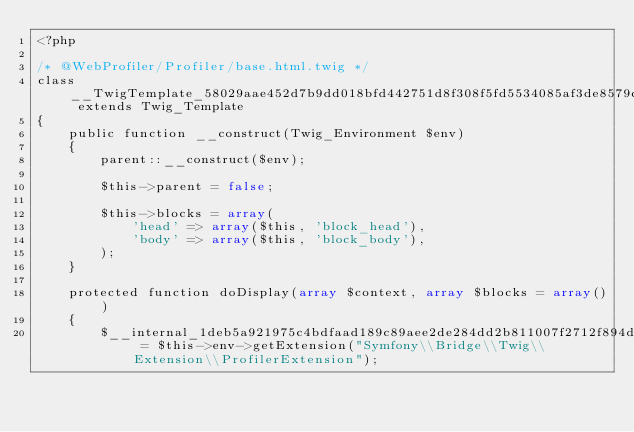Convert code to text. <code><loc_0><loc_0><loc_500><loc_500><_PHP_><?php

/* @WebProfiler/Profiler/base.html.twig */
class __TwigTemplate_58029aae452d7b9dd018bfd442751d8f308f5fd5534085af3de8579cfddcbffd extends Twig_Template
{
    public function __construct(Twig_Environment $env)
    {
        parent::__construct($env);

        $this->parent = false;

        $this->blocks = array(
            'head' => array($this, 'block_head'),
            'body' => array($this, 'block_body'),
        );
    }

    protected function doDisplay(array $context, array $blocks = array())
    {
        $__internal_1deb5a921975c4bdfaad189c89aee2de284dd2b811007f2712f894d72180fd0f = $this->env->getExtension("Symfony\\Bridge\\Twig\\Extension\\ProfilerExtension");</code> 